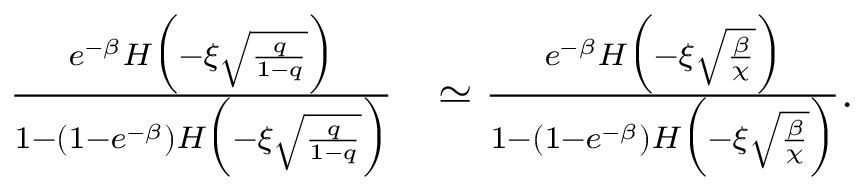<formula> <loc_0><loc_0><loc_500><loc_500>\begin{array} { r l } { \frac { e ^ { - \beta } H \left ( - \xi \sqrt { \frac { q } { 1 - q } } \right ) } { 1 - ( 1 - e ^ { - \beta } ) H \left ( - \xi \sqrt { \frac { q } { 1 - q } } \right ) } } & { \simeq \frac { e ^ { - \beta } H \left ( - \xi \sqrt { \frac { \beta } { \chi } } \right ) } { 1 - ( 1 - e ^ { - \beta } ) H \left ( - \xi \sqrt { \frac { \beta } { \chi } } \right ) } . } \end{array}</formula> 